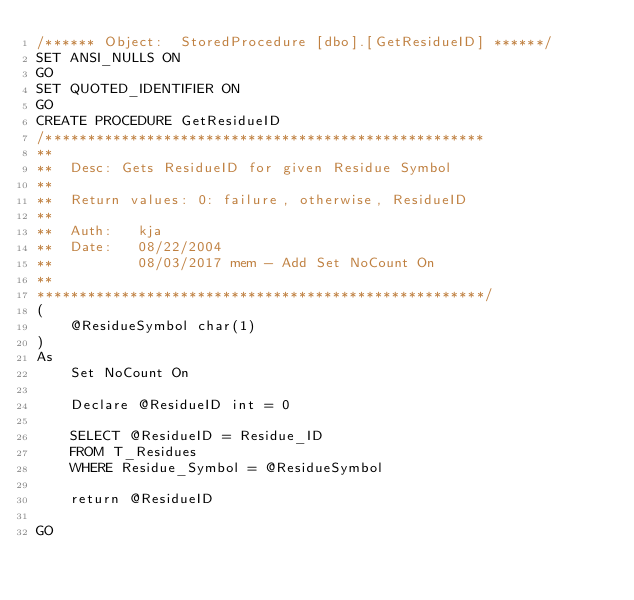Convert code to text. <code><loc_0><loc_0><loc_500><loc_500><_SQL_>/****** Object:  StoredProcedure [dbo].[GetResidueID] ******/
SET ANSI_NULLS ON
GO
SET QUOTED_IDENTIFIER ON
GO
CREATE PROCEDURE GetResidueID
/****************************************************
**
**	Desc: Gets ResidueID for given Residue Symbol
**
**	Return values: 0: failure, otherwise, ResidueID
**
**	Auth:	kja
**	Date:	08/22/2004
**			08/03/2017 mem - Add Set NoCount On
**    
*****************************************************/
(
	@ResidueSymbol char(1)
)
As
	Set NoCount On
	
	Declare @ResidueID int = 0
	
	SELECT @ResidueID = Residue_ID
	FROM T_Residues
	WHERE Residue_Symbol = @ResidueSymbol
	
	return @ResidueID

GO</code> 